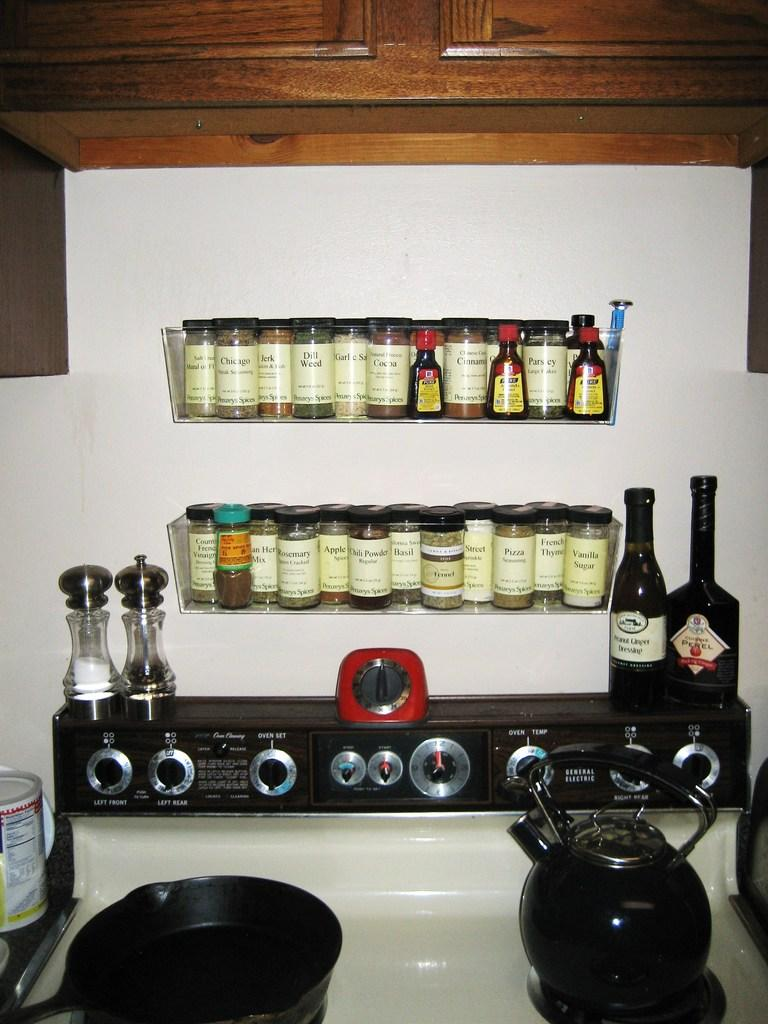<image>
Describe the image concisely. Kitchen Stove and Condiments on a shelf with 3 Mccormick bottles. 